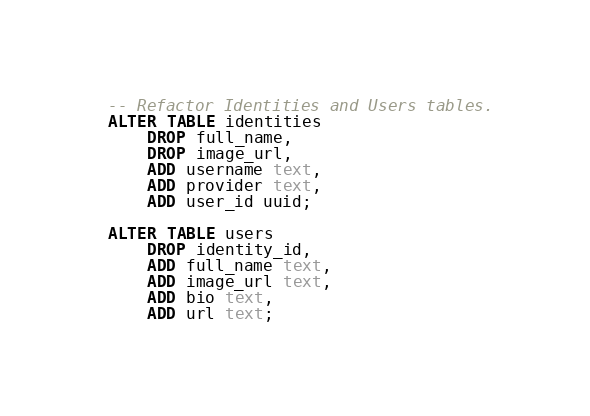Convert code to text. <code><loc_0><loc_0><loc_500><loc_500><_SQL_>-- Refactor Identities and Users tables.
ALTER TABLE identities
    DROP full_name,
    DROP image_url,
    ADD username text,
    ADD provider text,
    ADD user_id uuid;

ALTER TABLE users
    DROP identity_id,
    ADD full_name text,
    ADD image_url text,
    ADD bio text,
    ADD url text;</code> 